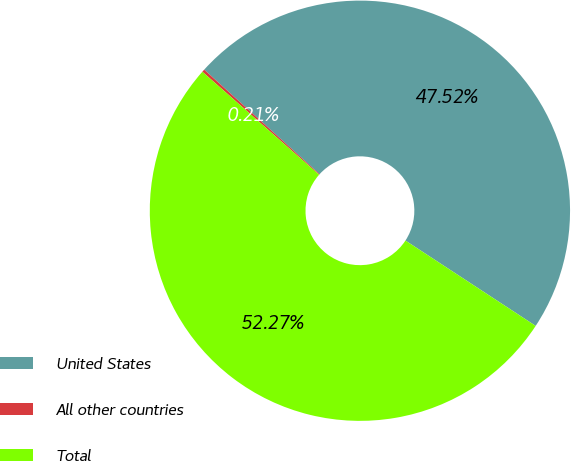<chart> <loc_0><loc_0><loc_500><loc_500><pie_chart><fcel>United States<fcel>All other countries<fcel>Total<nl><fcel>47.52%<fcel>0.21%<fcel>52.27%<nl></chart> 